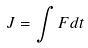Convert formula to latex. <formula><loc_0><loc_0><loc_500><loc_500>J = \int F d t</formula> 